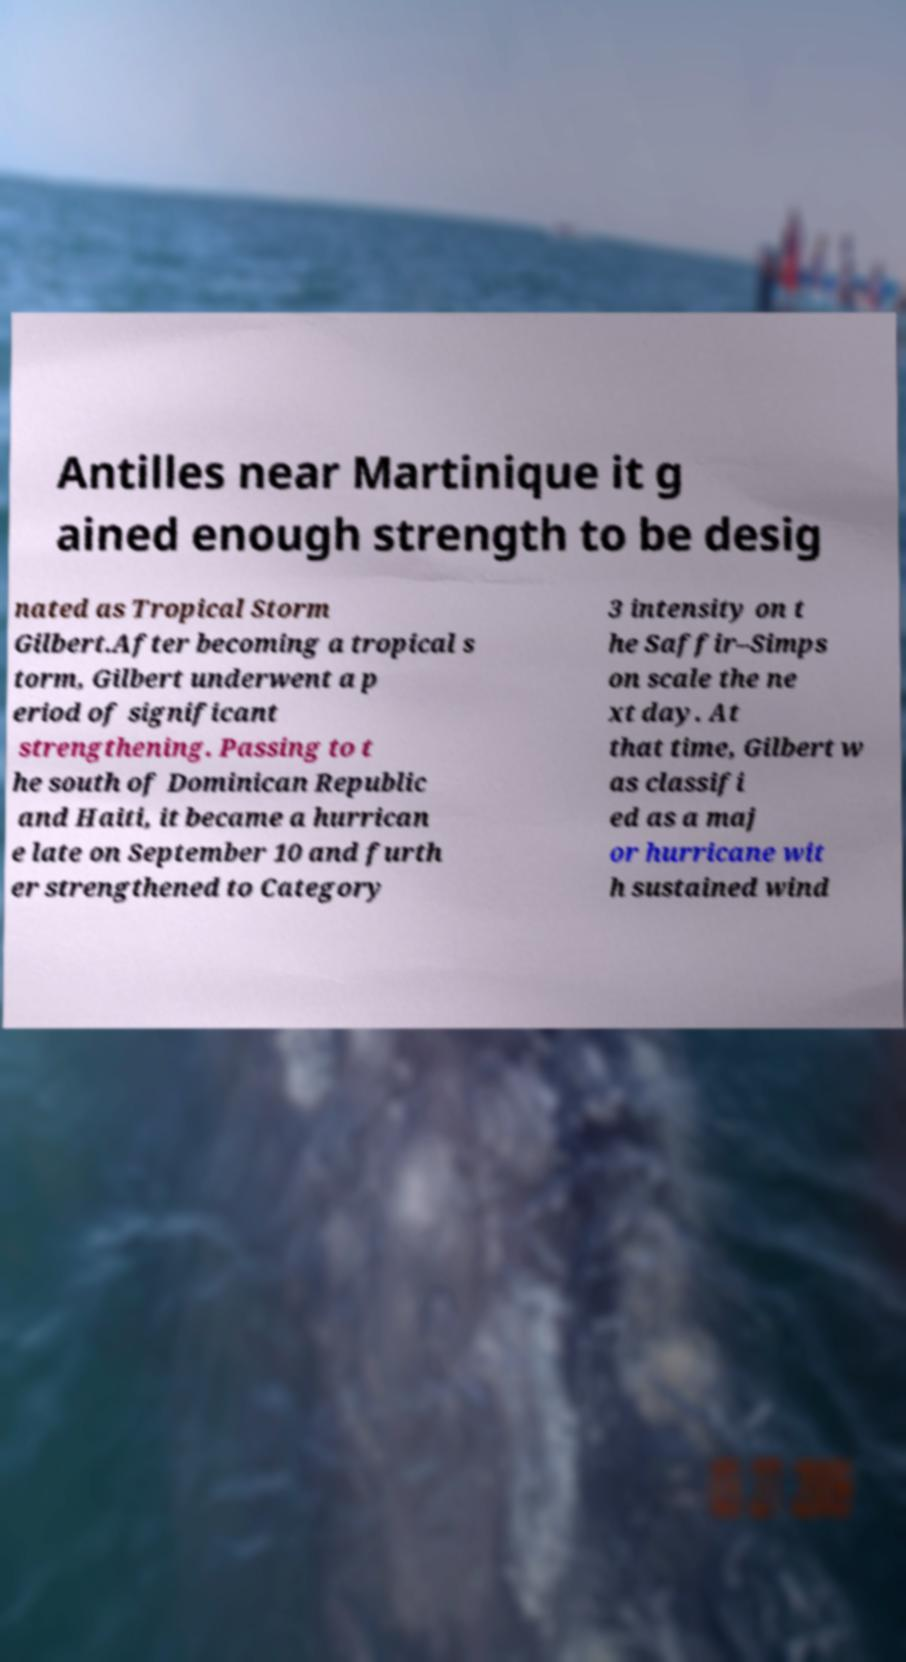Can you read and provide the text displayed in the image?This photo seems to have some interesting text. Can you extract and type it out for me? Antilles near Martinique it g ained enough strength to be desig nated as Tropical Storm Gilbert.After becoming a tropical s torm, Gilbert underwent a p eriod of significant strengthening. Passing to t he south of Dominican Republic and Haiti, it became a hurrican e late on September 10 and furth er strengthened to Category 3 intensity on t he Saffir–Simps on scale the ne xt day. At that time, Gilbert w as classifi ed as a maj or hurricane wit h sustained wind 